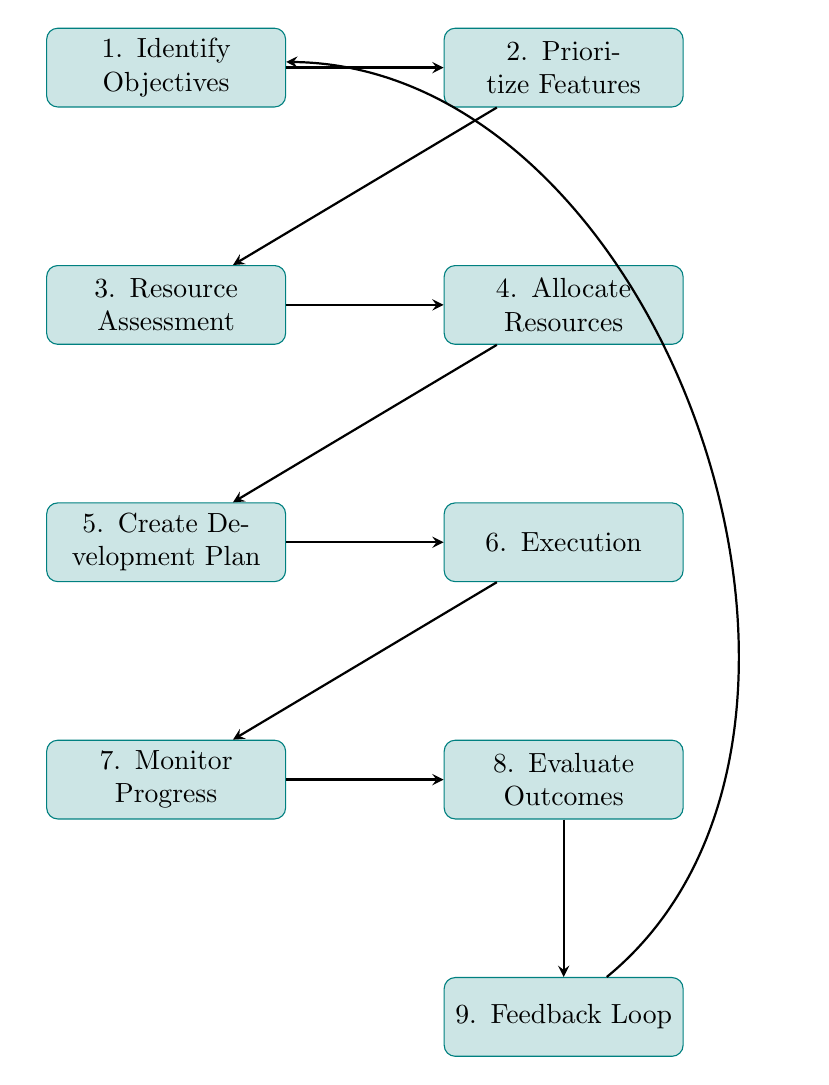What is the first step in the flow chart? The first step is "Identify Objectives," which is the initial node in the diagram.
Answer: Identify Objectives How many nodes are there in the flow chart? The flow chart contains a total of nine nodes representing different steps in the resource allocation process.
Answer: Nine After "Allocate Resources," what is the next step? The next step after "Allocate Resources" is "Create Development Plan," which is directly connected to it in the flow.
Answer: Create Development Plan Which step leads into "Monitor Progress"? The step that leads into "Monitor Progress" is "Execution," as the flow chart shows a direct arrow from "Execution" to "Monitor Progress."
Answer: Execution What relationship exists between "Evaluate Outcomes" and "Feedback Loop"? "Evaluate Outcomes" is followed by "Feedback Loop," indicating that one step leads to the next in the process of resource allocation.
Answer: Sequential What step is directly before "Evaluate Outcomes"? The step directly before "Evaluate Outcomes" is "Monitor Progress," creating a linear flow from monitoring to evaluation.
Answer: Monitor Progress What is the process that leads back to the beginning of the flow? The process that leads back to the beginning is the "Feedback Loop," which connects back to "Identify Objectives," indicating a cyclical nature of feedback.
Answer: Feedback Loop If a feature is assessed but not prioritized, what happens next? If a feature is assessed but not prioritized, it does not move forward in the flow to receive resources or a development plan, essentially halting its progress in the process.
Answer: Halted What is the purpose of the "Resource Assessment" step? The purpose of the "Resource Assessment" step is to analyze available resources, setting the stage for proper allocation of resources to the prioritized features.
Answer: Analyze resources 